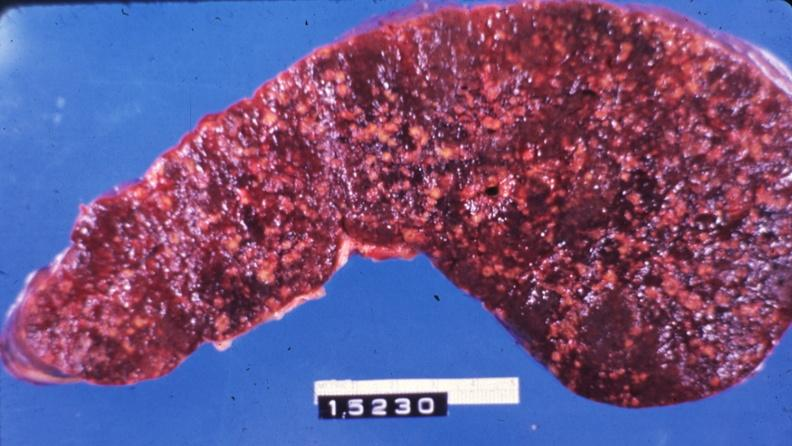does cortical nodule show slice of spleen with multiple nodules?
Answer the question using a single word or phrase. No 